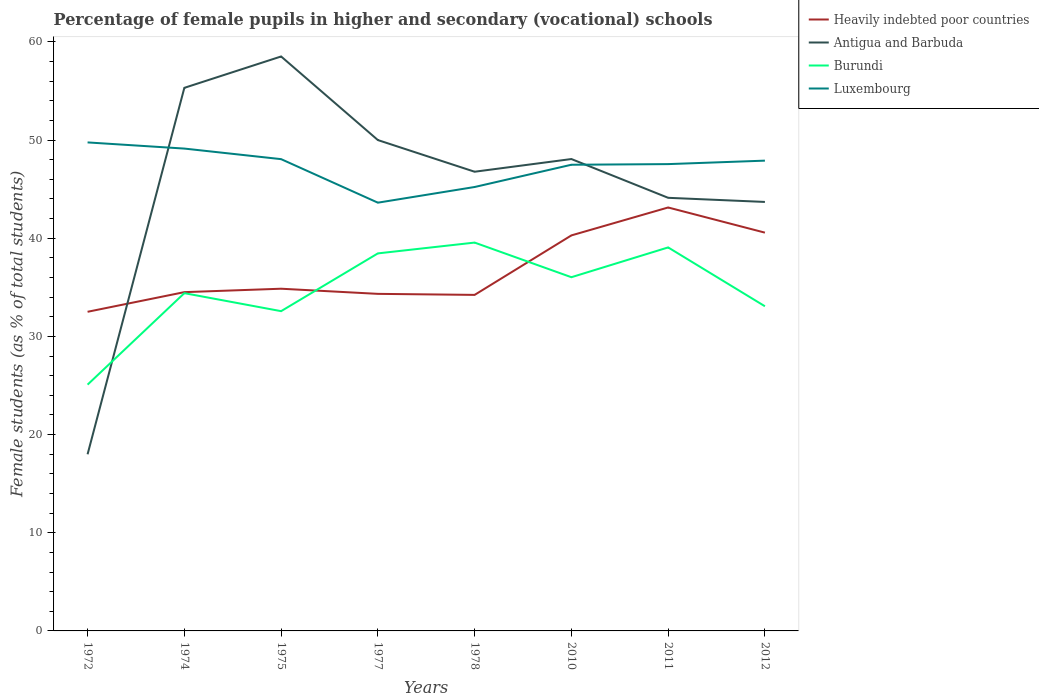How many different coloured lines are there?
Offer a very short reply. 4. Does the line corresponding to Burundi intersect with the line corresponding to Luxembourg?
Provide a succinct answer. No. Across all years, what is the maximum percentage of female pupils in higher and secondary schools in Luxembourg?
Keep it short and to the point. 43.62. In which year was the percentage of female pupils in higher and secondary schools in Burundi maximum?
Your response must be concise. 1972. What is the total percentage of female pupils in higher and secondary schools in Burundi in the graph?
Offer a very short reply. -4.05. What is the difference between the highest and the second highest percentage of female pupils in higher and secondary schools in Luxembourg?
Your answer should be very brief. 6.14. Is the percentage of female pupils in higher and secondary schools in Heavily indebted poor countries strictly greater than the percentage of female pupils in higher and secondary schools in Burundi over the years?
Keep it short and to the point. No. How many lines are there?
Offer a very short reply. 4. How many years are there in the graph?
Keep it short and to the point. 8. Are the values on the major ticks of Y-axis written in scientific E-notation?
Your response must be concise. No. Where does the legend appear in the graph?
Provide a short and direct response. Top right. How many legend labels are there?
Offer a very short reply. 4. What is the title of the graph?
Give a very brief answer. Percentage of female pupils in higher and secondary (vocational) schools. Does "Kosovo" appear as one of the legend labels in the graph?
Give a very brief answer. No. What is the label or title of the X-axis?
Give a very brief answer. Years. What is the label or title of the Y-axis?
Your answer should be very brief. Female students (as % of total students). What is the Female students (as % of total students) of Heavily indebted poor countries in 1972?
Provide a succinct answer. 32.51. What is the Female students (as % of total students) of Antigua and Barbuda in 1972?
Make the answer very short. 17.99. What is the Female students (as % of total students) in Burundi in 1972?
Your answer should be compact. 25.09. What is the Female students (as % of total students) of Luxembourg in 1972?
Offer a very short reply. 49.76. What is the Female students (as % of total students) in Heavily indebted poor countries in 1974?
Make the answer very short. 34.51. What is the Female students (as % of total students) in Antigua and Barbuda in 1974?
Make the answer very short. 55.32. What is the Female students (as % of total students) in Burundi in 1974?
Provide a succinct answer. 34.41. What is the Female students (as % of total students) of Luxembourg in 1974?
Ensure brevity in your answer.  49.13. What is the Female students (as % of total students) of Heavily indebted poor countries in 1975?
Give a very brief answer. 34.86. What is the Female students (as % of total students) of Antigua and Barbuda in 1975?
Give a very brief answer. 58.52. What is the Female students (as % of total students) of Burundi in 1975?
Make the answer very short. 32.57. What is the Female students (as % of total students) in Luxembourg in 1975?
Your answer should be compact. 48.06. What is the Female students (as % of total students) of Heavily indebted poor countries in 1977?
Your response must be concise. 34.33. What is the Female students (as % of total students) of Burundi in 1977?
Offer a very short reply. 38.46. What is the Female students (as % of total students) in Luxembourg in 1977?
Ensure brevity in your answer.  43.62. What is the Female students (as % of total students) of Heavily indebted poor countries in 1978?
Make the answer very short. 34.23. What is the Female students (as % of total students) in Antigua and Barbuda in 1978?
Provide a short and direct response. 46.77. What is the Female students (as % of total students) of Burundi in 1978?
Offer a terse response. 39.56. What is the Female students (as % of total students) in Luxembourg in 1978?
Offer a very short reply. 45.22. What is the Female students (as % of total students) of Heavily indebted poor countries in 2010?
Make the answer very short. 40.29. What is the Female students (as % of total students) in Antigua and Barbuda in 2010?
Offer a terse response. 48.07. What is the Female students (as % of total students) in Burundi in 2010?
Your answer should be compact. 36.03. What is the Female students (as % of total students) in Luxembourg in 2010?
Ensure brevity in your answer.  47.49. What is the Female students (as % of total students) of Heavily indebted poor countries in 2011?
Offer a very short reply. 43.13. What is the Female students (as % of total students) of Antigua and Barbuda in 2011?
Give a very brief answer. 44.12. What is the Female students (as % of total students) in Burundi in 2011?
Provide a short and direct response. 39.06. What is the Female students (as % of total students) of Luxembourg in 2011?
Your answer should be compact. 47.55. What is the Female students (as % of total students) of Heavily indebted poor countries in 2012?
Ensure brevity in your answer.  40.57. What is the Female students (as % of total students) in Antigua and Barbuda in 2012?
Your answer should be compact. 43.7. What is the Female students (as % of total students) in Burundi in 2012?
Make the answer very short. 33.07. What is the Female students (as % of total students) in Luxembourg in 2012?
Give a very brief answer. 47.9. Across all years, what is the maximum Female students (as % of total students) of Heavily indebted poor countries?
Provide a short and direct response. 43.13. Across all years, what is the maximum Female students (as % of total students) of Antigua and Barbuda?
Give a very brief answer. 58.52. Across all years, what is the maximum Female students (as % of total students) of Burundi?
Keep it short and to the point. 39.56. Across all years, what is the maximum Female students (as % of total students) in Luxembourg?
Your answer should be very brief. 49.76. Across all years, what is the minimum Female students (as % of total students) in Heavily indebted poor countries?
Make the answer very short. 32.51. Across all years, what is the minimum Female students (as % of total students) of Antigua and Barbuda?
Offer a very short reply. 17.99. Across all years, what is the minimum Female students (as % of total students) of Burundi?
Offer a very short reply. 25.09. Across all years, what is the minimum Female students (as % of total students) in Luxembourg?
Your response must be concise. 43.62. What is the total Female students (as % of total students) of Heavily indebted poor countries in the graph?
Provide a short and direct response. 294.43. What is the total Female students (as % of total students) of Antigua and Barbuda in the graph?
Give a very brief answer. 364.48. What is the total Female students (as % of total students) of Burundi in the graph?
Give a very brief answer. 278.24. What is the total Female students (as % of total students) of Luxembourg in the graph?
Give a very brief answer. 378.73. What is the difference between the Female students (as % of total students) in Heavily indebted poor countries in 1972 and that in 1974?
Keep it short and to the point. -2. What is the difference between the Female students (as % of total students) in Antigua and Barbuda in 1972 and that in 1974?
Keep it short and to the point. -37.33. What is the difference between the Female students (as % of total students) in Burundi in 1972 and that in 1974?
Offer a very short reply. -9.32. What is the difference between the Female students (as % of total students) in Luxembourg in 1972 and that in 1974?
Provide a succinct answer. 0.63. What is the difference between the Female students (as % of total students) of Heavily indebted poor countries in 1972 and that in 1975?
Provide a succinct answer. -2.35. What is the difference between the Female students (as % of total students) in Antigua and Barbuda in 1972 and that in 1975?
Keep it short and to the point. -40.52. What is the difference between the Female students (as % of total students) of Burundi in 1972 and that in 1975?
Ensure brevity in your answer.  -7.49. What is the difference between the Female students (as % of total students) of Luxembourg in 1972 and that in 1975?
Ensure brevity in your answer.  1.7. What is the difference between the Female students (as % of total students) of Heavily indebted poor countries in 1972 and that in 1977?
Provide a short and direct response. -1.83. What is the difference between the Female students (as % of total students) of Antigua and Barbuda in 1972 and that in 1977?
Provide a succinct answer. -32.01. What is the difference between the Female students (as % of total students) in Burundi in 1972 and that in 1977?
Offer a terse response. -13.37. What is the difference between the Female students (as % of total students) in Luxembourg in 1972 and that in 1977?
Your answer should be compact. 6.14. What is the difference between the Female students (as % of total students) of Heavily indebted poor countries in 1972 and that in 1978?
Your response must be concise. -1.72. What is the difference between the Female students (as % of total students) of Antigua and Barbuda in 1972 and that in 1978?
Provide a succinct answer. -28.78. What is the difference between the Female students (as % of total students) of Burundi in 1972 and that in 1978?
Ensure brevity in your answer.  -14.47. What is the difference between the Female students (as % of total students) of Luxembourg in 1972 and that in 1978?
Offer a very short reply. 4.54. What is the difference between the Female students (as % of total students) in Heavily indebted poor countries in 1972 and that in 2010?
Your answer should be compact. -7.78. What is the difference between the Female students (as % of total students) in Antigua and Barbuda in 1972 and that in 2010?
Keep it short and to the point. -30.08. What is the difference between the Female students (as % of total students) of Burundi in 1972 and that in 2010?
Provide a succinct answer. -10.94. What is the difference between the Female students (as % of total students) in Luxembourg in 1972 and that in 2010?
Your response must be concise. 2.27. What is the difference between the Female students (as % of total students) of Heavily indebted poor countries in 1972 and that in 2011?
Your answer should be compact. -10.62. What is the difference between the Female students (as % of total students) of Antigua and Barbuda in 1972 and that in 2011?
Your answer should be compact. -26.13. What is the difference between the Female students (as % of total students) in Burundi in 1972 and that in 2011?
Your answer should be compact. -13.98. What is the difference between the Female students (as % of total students) of Luxembourg in 1972 and that in 2011?
Give a very brief answer. 2.21. What is the difference between the Female students (as % of total students) in Heavily indebted poor countries in 1972 and that in 2012?
Offer a very short reply. -8.06. What is the difference between the Female students (as % of total students) of Antigua and Barbuda in 1972 and that in 2012?
Provide a succinct answer. -25.71. What is the difference between the Female students (as % of total students) in Burundi in 1972 and that in 2012?
Your response must be concise. -7.98. What is the difference between the Female students (as % of total students) in Luxembourg in 1972 and that in 2012?
Give a very brief answer. 1.86. What is the difference between the Female students (as % of total students) in Heavily indebted poor countries in 1974 and that in 1975?
Keep it short and to the point. -0.35. What is the difference between the Female students (as % of total students) of Antigua and Barbuda in 1974 and that in 1975?
Your answer should be very brief. -3.2. What is the difference between the Female students (as % of total students) of Burundi in 1974 and that in 1975?
Your answer should be compact. 1.83. What is the difference between the Female students (as % of total students) of Luxembourg in 1974 and that in 1975?
Ensure brevity in your answer.  1.08. What is the difference between the Female students (as % of total students) in Heavily indebted poor countries in 1974 and that in 1977?
Provide a short and direct response. 0.18. What is the difference between the Female students (as % of total students) of Antigua and Barbuda in 1974 and that in 1977?
Give a very brief answer. 5.32. What is the difference between the Female students (as % of total students) in Burundi in 1974 and that in 1977?
Your response must be concise. -4.05. What is the difference between the Female students (as % of total students) in Luxembourg in 1974 and that in 1977?
Your answer should be compact. 5.51. What is the difference between the Female students (as % of total students) in Heavily indebted poor countries in 1974 and that in 1978?
Provide a short and direct response. 0.28. What is the difference between the Female students (as % of total students) of Antigua and Barbuda in 1974 and that in 1978?
Your response must be concise. 8.54. What is the difference between the Female students (as % of total students) of Burundi in 1974 and that in 1978?
Make the answer very short. -5.15. What is the difference between the Female students (as % of total students) in Luxembourg in 1974 and that in 1978?
Provide a short and direct response. 3.91. What is the difference between the Female students (as % of total students) in Heavily indebted poor countries in 1974 and that in 2010?
Your answer should be compact. -5.78. What is the difference between the Female students (as % of total students) in Antigua and Barbuda in 1974 and that in 2010?
Offer a very short reply. 7.25. What is the difference between the Female students (as % of total students) in Burundi in 1974 and that in 2010?
Provide a short and direct response. -1.62. What is the difference between the Female students (as % of total students) of Luxembourg in 1974 and that in 2010?
Offer a very short reply. 1.65. What is the difference between the Female students (as % of total students) in Heavily indebted poor countries in 1974 and that in 2011?
Ensure brevity in your answer.  -8.62. What is the difference between the Female students (as % of total students) of Antigua and Barbuda in 1974 and that in 2011?
Your response must be concise. 11.2. What is the difference between the Female students (as % of total students) in Burundi in 1974 and that in 2011?
Give a very brief answer. -4.66. What is the difference between the Female students (as % of total students) in Luxembourg in 1974 and that in 2011?
Your answer should be compact. 1.58. What is the difference between the Female students (as % of total students) of Heavily indebted poor countries in 1974 and that in 2012?
Provide a succinct answer. -6.06. What is the difference between the Female students (as % of total students) in Antigua and Barbuda in 1974 and that in 2012?
Make the answer very short. 11.62. What is the difference between the Female students (as % of total students) of Burundi in 1974 and that in 2012?
Ensure brevity in your answer.  1.33. What is the difference between the Female students (as % of total students) of Luxembourg in 1974 and that in 2012?
Ensure brevity in your answer.  1.23. What is the difference between the Female students (as % of total students) of Heavily indebted poor countries in 1975 and that in 1977?
Make the answer very short. 0.52. What is the difference between the Female students (as % of total students) of Antigua and Barbuda in 1975 and that in 1977?
Offer a very short reply. 8.52. What is the difference between the Female students (as % of total students) of Burundi in 1975 and that in 1977?
Your response must be concise. -5.88. What is the difference between the Female students (as % of total students) in Luxembourg in 1975 and that in 1977?
Offer a terse response. 4.43. What is the difference between the Female students (as % of total students) of Heavily indebted poor countries in 1975 and that in 1978?
Your answer should be very brief. 0.63. What is the difference between the Female students (as % of total students) of Antigua and Barbuda in 1975 and that in 1978?
Offer a terse response. 11.74. What is the difference between the Female students (as % of total students) of Burundi in 1975 and that in 1978?
Keep it short and to the point. -6.98. What is the difference between the Female students (as % of total students) in Luxembourg in 1975 and that in 1978?
Offer a very short reply. 2.84. What is the difference between the Female students (as % of total students) of Heavily indebted poor countries in 1975 and that in 2010?
Provide a short and direct response. -5.43. What is the difference between the Female students (as % of total students) in Antigua and Barbuda in 1975 and that in 2010?
Provide a succinct answer. 10.45. What is the difference between the Female students (as % of total students) of Burundi in 1975 and that in 2010?
Offer a very short reply. -3.46. What is the difference between the Female students (as % of total students) of Luxembourg in 1975 and that in 2010?
Your answer should be compact. 0.57. What is the difference between the Female students (as % of total students) of Heavily indebted poor countries in 1975 and that in 2011?
Keep it short and to the point. -8.27. What is the difference between the Female students (as % of total students) of Antigua and Barbuda in 1975 and that in 2011?
Give a very brief answer. 14.4. What is the difference between the Female students (as % of total students) of Burundi in 1975 and that in 2011?
Your response must be concise. -6.49. What is the difference between the Female students (as % of total students) in Luxembourg in 1975 and that in 2011?
Keep it short and to the point. 0.51. What is the difference between the Female students (as % of total students) of Heavily indebted poor countries in 1975 and that in 2012?
Offer a terse response. -5.71. What is the difference between the Female students (as % of total students) of Antigua and Barbuda in 1975 and that in 2012?
Make the answer very short. 14.82. What is the difference between the Female students (as % of total students) in Burundi in 1975 and that in 2012?
Ensure brevity in your answer.  -0.5. What is the difference between the Female students (as % of total students) in Luxembourg in 1975 and that in 2012?
Give a very brief answer. 0.15. What is the difference between the Female students (as % of total students) in Heavily indebted poor countries in 1977 and that in 1978?
Your response must be concise. 0.1. What is the difference between the Female students (as % of total students) in Antigua and Barbuda in 1977 and that in 1978?
Provide a short and direct response. 3.23. What is the difference between the Female students (as % of total students) of Burundi in 1977 and that in 1978?
Provide a short and direct response. -1.1. What is the difference between the Female students (as % of total students) of Luxembourg in 1977 and that in 1978?
Ensure brevity in your answer.  -1.6. What is the difference between the Female students (as % of total students) in Heavily indebted poor countries in 1977 and that in 2010?
Ensure brevity in your answer.  -5.96. What is the difference between the Female students (as % of total students) of Antigua and Barbuda in 1977 and that in 2010?
Offer a very short reply. 1.93. What is the difference between the Female students (as % of total students) in Burundi in 1977 and that in 2010?
Make the answer very short. 2.43. What is the difference between the Female students (as % of total students) in Luxembourg in 1977 and that in 2010?
Give a very brief answer. -3.86. What is the difference between the Female students (as % of total students) in Heavily indebted poor countries in 1977 and that in 2011?
Ensure brevity in your answer.  -8.8. What is the difference between the Female students (as % of total students) of Antigua and Barbuda in 1977 and that in 2011?
Your answer should be compact. 5.88. What is the difference between the Female students (as % of total students) in Burundi in 1977 and that in 2011?
Offer a very short reply. -0.61. What is the difference between the Female students (as % of total students) of Luxembourg in 1977 and that in 2011?
Offer a terse response. -3.93. What is the difference between the Female students (as % of total students) of Heavily indebted poor countries in 1977 and that in 2012?
Keep it short and to the point. -6.24. What is the difference between the Female students (as % of total students) of Antigua and Barbuda in 1977 and that in 2012?
Provide a succinct answer. 6.3. What is the difference between the Female students (as % of total students) in Burundi in 1977 and that in 2012?
Give a very brief answer. 5.39. What is the difference between the Female students (as % of total students) in Luxembourg in 1977 and that in 2012?
Keep it short and to the point. -4.28. What is the difference between the Female students (as % of total students) of Heavily indebted poor countries in 1978 and that in 2010?
Provide a short and direct response. -6.06. What is the difference between the Female students (as % of total students) of Antigua and Barbuda in 1978 and that in 2010?
Offer a terse response. -1.29. What is the difference between the Female students (as % of total students) of Burundi in 1978 and that in 2010?
Offer a very short reply. 3.53. What is the difference between the Female students (as % of total students) in Luxembourg in 1978 and that in 2010?
Provide a short and direct response. -2.27. What is the difference between the Female students (as % of total students) in Heavily indebted poor countries in 1978 and that in 2011?
Keep it short and to the point. -8.9. What is the difference between the Female students (as % of total students) of Antigua and Barbuda in 1978 and that in 2011?
Provide a succinct answer. 2.66. What is the difference between the Female students (as % of total students) of Burundi in 1978 and that in 2011?
Provide a succinct answer. 0.49. What is the difference between the Female students (as % of total students) of Luxembourg in 1978 and that in 2011?
Provide a short and direct response. -2.33. What is the difference between the Female students (as % of total students) in Heavily indebted poor countries in 1978 and that in 2012?
Keep it short and to the point. -6.34. What is the difference between the Female students (as % of total students) in Antigua and Barbuda in 1978 and that in 2012?
Provide a succinct answer. 3.08. What is the difference between the Female students (as % of total students) of Burundi in 1978 and that in 2012?
Provide a succinct answer. 6.49. What is the difference between the Female students (as % of total students) in Luxembourg in 1978 and that in 2012?
Offer a very short reply. -2.69. What is the difference between the Female students (as % of total students) in Heavily indebted poor countries in 2010 and that in 2011?
Keep it short and to the point. -2.84. What is the difference between the Female students (as % of total students) of Antigua and Barbuda in 2010 and that in 2011?
Offer a terse response. 3.95. What is the difference between the Female students (as % of total students) in Burundi in 2010 and that in 2011?
Offer a terse response. -3.04. What is the difference between the Female students (as % of total students) of Luxembourg in 2010 and that in 2011?
Make the answer very short. -0.06. What is the difference between the Female students (as % of total students) in Heavily indebted poor countries in 2010 and that in 2012?
Make the answer very short. -0.28. What is the difference between the Female students (as % of total students) in Antigua and Barbuda in 2010 and that in 2012?
Ensure brevity in your answer.  4.37. What is the difference between the Female students (as % of total students) in Burundi in 2010 and that in 2012?
Offer a very short reply. 2.96. What is the difference between the Female students (as % of total students) in Luxembourg in 2010 and that in 2012?
Give a very brief answer. -0.42. What is the difference between the Female students (as % of total students) of Heavily indebted poor countries in 2011 and that in 2012?
Offer a terse response. 2.56. What is the difference between the Female students (as % of total students) of Antigua and Barbuda in 2011 and that in 2012?
Your answer should be compact. 0.42. What is the difference between the Female students (as % of total students) of Burundi in 2011 and that in 2012?
Make the answer very short. 5.99. What is the difference between the Female students (as % of total students) of Luxembourg in 2011 and that in 2012?
Your answer should be compact. -0.35. What is the difference between the Female students (as % of total students) in Heavily indebted poor countries in 1972 and the Female students (as % of total students) in Antigua and Barbuda in 1974?
Provide a short and direct response. -22.81. What is the difference between the Female students (as % of total students) of Heavily indebted poor countries in 1972 and the Female students (as % of total students) of Burundi in 1974?
Provide a short and direct response. -1.9. What is the difference between the Female students (as % of total students) of Heavily indebted poor countries in 1972 and the Female students (as % of total students) of Luxembourg in 1974?
Give a very brief answer. -16.63. What is the difference between the Female students (as % of total students) in Antigua and Barbuda in 1972 and the Female students (as % of total students) in Burundi in 1974?
Provide a short and direct response. -16.41. What is the difference between the Female students (as % of total students) in Antigua and Barbuda in 1972 and the Female students (as % of total students) in Luxembourg in 1974?
Give a very brief answer. -31.14. What is the difference between the Female students (as % of total students) of Burundi in 1972 and the Female students (as % of total students) of Luxembourg in 1974?
Keep it short and to the point. -24.05. What is the difference between the Female students (as % of total students) in Heavily indebted poor countries in 1972 and the Female students (as % of total students) in Antigua and Barbuda in 1975?
Provide a succinct answer. -26.01. What is the difference between the Female students (as % of total students) of Heavily indebted poor countries in 1972 and the Female students (as % of total students) of Burundi in 1975?
Make the answer very short. -0.07. What is the difference between the Female students (as % of total students) of Heavily indebted poor countries in 1972 and the Female students (as % of total students) of Luxembourg in 1975?
Provide a succinct answer. -15.55. What is the difference between the Female students (as % of total students) in Antigua and Barbuda in 1972 and the Female students (as % of total students) in Burundi in 1975?
Offer a very short reply. -14.58. What is the difference between the Female students (as % of total students) of Antigua and Barbuda in 1972 and the Female students (as % of total students) of Luxembourg in 1975?
Keep it short and to the point. -30.07. What is the difference between the Female students (as % of total students) in Burundi in 1972 and the Female students (as % of total students) in Luxembourg in 1975?
Make the answer very short. -22.97. What is the difference between the Female students (as % of total students) in Heavily indebted poor countries in 1972 and the Female students (as % of total students) in Antigua and Barbuda in 1977?
Keep it short and to the point. -17.49. What is the difference between the Female students (as % of total students) of Heavily indebted poor countries in 1972 and the Female students (as % of total students) of Burundi in 1977?
Give a very brief answer. -5.95. What is the difference between the Female students (as % of total students) of Heavily indebted poor countries in 1972 and the Female students (as % of total students) of Luxembourg in 1977?
Make the answer very short. -11.12. What is the difference between the Female students (as % of total students) of Antigua and Barbuda in 1972 and the Female students (as % of total students) of Burundi in 1977?
Provide a succinct answer. -20.46. What is the difference between the Female students (as % of total students) in Antigua and Barbuda in 1972 and the Female students (as % of total students) in Luxembourg in 1977?
Offer a very short reply. -25.63. What is the difference between the Female students (as % of total students) in Burundi in 1972 and the Female students (as % of total students) in Luxembourg in 1977?
Your answer should be compact. -18.54. What is the difference between the Female students (as % of total students) of Heavily indebted poor countries in 1972 and the Female students (as % of total students) of Antigua and Barbuda in 1978?
Your answer should be compact. -14.27. What is the difference between the Female students (as % of total students) of Heavily indebted poor countries in 1972 and the Female students (as % of total students) of Burundi in 1978?
Offer a terse response. -7.05. What is the difference between the Female students (as % of total students) in Heavily indebted poor countries in 1972 and the Female students (as % of total students) in Luxembourg in 1978?
Your response must be concise. -12.71. What is the difference between the Female students (as % of total students) of Antigua and Barbuda in 1972 and the Female students (as % of total students) of Burundi in 1978?
Offer a very short reply. -21.57. What is the difference between the Female students (as % of total students) in Antigua and Barbuda in 1972 and the Female students (as % of total students) in Luxembourg in 1978?
Your answer should be compact. -27.23. What is the difference between the Female students (as % of total students) of Burundi in 1972 and the Female students (as % of total students) of Luxembourg in 1978?
Your response must be concise. -20.13. What is the difference between the Female students (as % of total students) of Heavily indebted poor countries in 1972 and the Female students (as % of total students) of Antigua and Barbuda in 2010?
Give a very brief answer. -15.56. What is the difference between the Female students (as % of total students) of Heavily indebted poor countries in 1972 and the Female students (as % of total students) of Burundi in 2010?
Offer a terse response. -3.52. What is the difference between the Female students (as % of total students) in Heavily indebted poor countries in 1972 and the Female students (as % of total students) in Luxembourg in 2010?
Offer a terse response. -14.98. What is the difference between the Female students (as % of total students) in Antigua and Barbuda in 1972 and the Female students (as % of total students) in Burundi in 2010?
Your answer should be compact. -18.04. What is the difference between the Female students (as % of total students) in Antigua and Barbuda in 1972 and the Female students (as % of total students) in Luxembourg in 2010?
Your answer should be very brief. -29.49. What is the difference between the Female students (as % of total students) in Burundi in 1972 and the Female students (as % of total students) in Luxembourg in 2010?
Provide a short and direct response. -22.4. What is the difference between the Female students (as % of total students) in Heavily indebted poor countries in 1972 and the Female students (as % of total students) in Antigua and Barbuda in 2011?
Make the answer very short. -11.61. What is the difference between the Female students (as % of total students) of Heavily indebted poor countries in 1972 and the Female students (as % of total students) of Burundi in 2011?
Offer a very short reply. -6.56. What is the difference between the Female students (as % of total students) of Heavily indebted poor countries in 1972 and the Female students (as % of total students) of Luxembourg in 2011?
Your response must be concise. -15.04. What is the difference between the Female students (as % of total students) in Antigua and Barbuda in 1972 and the Female students (as % of total students) in Burundi in 2011?
Your response must be concise. -21.07. What is the difference between the Female students (as % of total students) in Antigua and Barbuda in 1972 and the Female students (as % of total students) in Luxembourg in 2011?
Give a very brief answer. -29.56. What is the difference between the Female students (as % of total students) of Burundi in 1972 and the Female students (as % of total students) of Luxembourg in 2011?
Provide a short and direct response. -22.46. What is the difference between the Female students (as % of total students) in Heavily indebted poor countries in 1972 and the Female students (as % of total students) in Antigua and Barbuda in 2012?
Ensure brevity in your answer.  -11.19. What is the difference between the Female students (as % of total students) in Heavily indebted poor countries in 1972 and the Female students (as % of total students) in Burundi in 2012?
Ensure brevity in your answer.  -0.56. What is the difference between the Female students (as % of total students) in Heavily indebted poor countries in 1972 and the Female students (as % of total students) in Luxembourg in 2012?
Provide a succinct answer. -15.4. What is the difference between the Female students (as % of total students) in Antigua and Barbuda in 1972 and the Female students (as % of total students) in Burundi in 2012?
Offer a very short reply. -15.08. What is the difference between the Female students (as % of total students) in Antigua and Barbuda in 1972 and the Female students (as % of total students) in Luxembourg in 2012?
Offer a terse response. -29.91. What is the difference between the Female students (as % of total students) in Burundi in 1972 and the Female students (as % of total students) in Luxembourg in 2012?
Make the answer very short. -22.82. What is the difference between the Female students (as % of total students) in Heavily indebted poor countries in 1974 and the Female students (as % of total students) in Antigua and Barbuda in 1975?
Offer a terse response. -24.01. What is the difference between the Female students (as % of total students) of Heavily indebted poor countries in 1974 and the Female students (as % of total students) of Burundi in 1975?
Provide a succinct answer. 1.94. What is the difference between the Female students (as % of total students) in Heavily indebted poor countries in 1974 and the Female students (as % of total students) in Luxembourg in 1975?
Your answer should be very brief. -13.55. What is the difference between the Female students (as % of total students) of Antigua and Barbuda in 1974 and the Female students (as % of total students) of Burundi in 1975?
Your answer should be very brief. 22.75. What is the difference between the Female students (as % of total students) in Antigua and Barbuda in 1974 and the Female students (as % of total students) in Luxembourg in 1975?
Keep it short and to the point. 7.26. What is the difference between the Female students (as % of total students) of Burundi in 1974 and the Female students (as % of total students) of Luxembourg in 1975?
Provide a succinct answer. -13.65. What is the difference between the Female students (as % of total students) in Heavily indebted poor countries in 1974 and the Female students (as % of total students) in Antigua and Barbuda in 1977?
Make the answer very short. -15.49. What is the difference between the Female students (as % of total students) of Heavily indebted poor countries in 1974 and the Female students (as % of total students) of Burundi in 1977?
Ensure brevity in your answer.  -3.95. What is the difference between the Female students (as % of total students) in Heavily indebted poor countries in 1974 and the Female students (as % of total students) in Luxembourg in 1977?
Give a very brief answer. -9.11. What is the difference between the Female students (as % of total students) of Antigua and Barbuda in 1974 and the Female students (as % of total students) of Burundi in 1977?
Ensure brevity in your answer.  16.86. What is the difference between the Female students (as % of total students) of Antigua and Barbuda in 1974 and the Female students (as % of total students) of Luxembourg in 1977?
Ensure brevity in your answer.  11.7. What is the difference between the Female students (as % of total students) of Burundi in 1974 and the Female students (as % of total students) of Luxembourg in 1977?
Your answer should be compact. -9.22. What is the difference between the Female students (as % of total students) of Heavily indebted poor countries in 1974 and the Female students (as % of total students) of Antigua and Barbuda in 1978?
Your answer should be compact. -12.27. What is the difference between the Female students (as % of total students) in Heavily indebted poor countries in 1974 and the Female students (as % of total students) in Burundi in 1978?
Your answer should be compact. -5.05. What is the difference between the Female students (as % of total students) of Heavily indebted poor countries in 1974 and the Female students (as % of total students) of Luxembourg in 1978?
Give a very brief answer. -10.71. What is the difference between the Female students (as % of total students) in Antigua and Barbuda in 1974 and the Female students (as % of total students) in Burundi in 1978?
Make the answer very short. 15.76. What is the difference between the Female students (as % of total students) in Antigua and Barbuda in 1974 and the Female students (as % of total students) in Luxembourg in 1978?
Your answer should be very brief. 10.1. What is the difference between the Female students (as % of total students) in Burundi in 1974 and the Female students (as % of total students) in Luxembourg in 1978?
Keep it short and to the point. -10.81. What is the difference between the Female students (as % of total students) in Heavily indebted poor countries in 1974 and the Female students (as % of total students) in Antigua and Barbuda in 2010?
Provide a short and direct response. -13.56. What is the difference between the Female students (as % of total students) of Heavily indebted poor countries in 1974 and the Female students (as % of total students) of Burundi in 2010?
Keep it short and to the point. -1.52. What is the difference between the Female students (as % of total students) in Heavily indebted poor countries in 1974 and the Female students (as % of total students) in Luxembourg in 2010?
Your response must be concise. -12.98. What is the difference between the Female students (as % of total students) in Antigua and Barbuda in 1974 and the Female students (as % of total students) in Burundi in 2010?
Make the answer very short. 19.29. What is the difference between the Female students (as % of total students) in Antigua and Barbuda in 1974 and the Female students (as % of total students) in Luxembourg in 2010?
Your response must be concise. 7.83. What is the difference between the Female students (as % of total students) in Burundi in 1974 and the Female students (as % of total students) in Luxembourg in 2010?
Make the answer very short. -13.08. What is the difference between the Female students (as % of total students) of Heavily indebted poor countries in 1974 and the Female students (as % of total students) of Antigua and Barbuda in 2011?
Your answer should be compact. -9.61. What is the difference between the Female students (as % of total students) of Heavily indebted poor countries in 1974 and the Female students (as % of total students) of Burundi in 2011?
Your answer should be very brief. -4.56. What is the difference between the Female students (as % of total students) in Heavily indebted poor countries in 1974 and the Female students (as % of total students) in Luxembourg in 2011?
Provide a short and direct response. -13.04. What is the difference between the Female students (as % of total students) of Antigua and Barbuda in 1974 and the Female students (as % of total students) of Burundi in 2011?
Keep it short and to the point. 16.25. What is the difference between the Female students (as % of total students) of Antigua and Barbuda in 1974 and the Female students (as % of total students) of Luxembourg in 2011?
Your response must be concise. 7.77. What is the difference between the Female students (as % of total students) in Burundi in 1974 and the Female students (as % of total students) in Luxembourg in 2011?
Keep it short and to the point. -13.14. What is the difference between the Female students (as % of total students) in Heavily indebted poor countries in 1974 and the Female students (as % of total students) in Antigua and Barbuda in 2012?
Offer a terse response. -9.19. What is the difference between the Female students (as % of total students) of Heavily indebted poor countries in 1974 and the Female students (as % of total students) of Burundi in 2012?
Keep it short and to the point. 1.44. What is the difference between the Female students (as % of total students) in Heavily indebted poor countries in 1974 and the Female students (as % of total students) in Luxembourg in 2012?
Give a very brief answer. -13.4. What is the difference between the Female students (as % of total students) in Antigua and Barbuda in 1974 and the Female students (as % of total students) in Burundi in 2012?
Offer a very short reply. 22.25. What is the difference between the Female students (as % of total students) of Antigua and Barbuda in 1974 and the Female students (as % of total students) of Luxembourg in 2012?
Offer a terse response. 7.42. What is the difference between the Female students (as % of total students) of Burundi in 1974 and the Female students (as % of total students) of Luxembourg in 2012?
Offer a terse response. -13.5. What is the difference between the Female students (as % of total students) of Heavily indebted poor countries in 1975 and the Female students (as % of total students) of Antigua and Barbuda in 1977?
Provide a short and direct response. -15.14. What is the difference between the Female students (as % of total students) of Heavily indebted poor countries in 1975 and the Female students (as % of total students) of Burundi in 1977?
Keep it short and to the point. -3.6. What is the difference between the Female students (as % of total students) in Heavily indebted poor countries in 1975 and the Female students (as % of total students) in Luxembourg in 1977?
Offer a very short reply. -8.76. What is the difference between the Female students (as % of total students) of Antigua and Barbuda in 1975 and the Female students (as % of total students) of Burundi in 1977?
Provide a short and direct response. 20.06. What is the difference between the Female students (as % of total students) of Antigua and Barbuda in 1975 and the Female students (as % of total students) of Luxembourg in 1977?
Offer a very short reply. 14.89. What is the difference between the Female students (as % of total students) in Burundi in 1975 and the Female students (as % of total students) in Luxembourg in 1977?
Offer a very short reply. -11.05. What is the difference between the Female students (as % of total students) of Heavily indebted poor countries in 1975 and the Female students (as % of total students) of Antigua and Barbuda in 1978?
Your response must be concise. -11.92. What is the difference between the Female students (as % of total students) of Heavily indebted poor countries in 1975 and the Female students (as % of total students) of Burundi in 1978?
Offer a very short reply. -4.7. What is the difference between the Female students (as % of total students) of Heavily indebted poor countries in 1975 and the Female students (as % of total students) of Luxembourg in 1978?
Provide a succinct answer. -10.36. What is the difference between the Female students (as % of total students) of Antigua and Barbuda in 1975 and the Female students (as % of total students) of Burundi in 1978?
Your answer should be very brief. 18.96. What is the difference between the Female students (as % of total students) in Antigua and Barbuda in 1975 and the Female students (as % of total students) in Luxembourg in 1978?
Offer a very short reply. 13.3. What is the difference between the Female students (as % of total students) of Burundi in 1975 and the Female students (as % of total students) of Luxembourg in 1978?
Offer a terse response. -12.65. What is the difference between the Female students (as % of total students) of Heavily indebted poor countries in 1975 and the Female students (as % of total students) of Antigua and Barbuda in 2010?
Give a very brief answer. -13.21. What is the difference between the Female students (as % of total students) in Heavily indebted poor countries in 1975 and the Female students (as % of total students) in Burundi in 2010?
Give a very brief answer. -1.17. What is the difference between the Female students (as % of total students) of Heavily indebted poor countries in 1975 and the Female students (as % of total students) of Luxembourg in 2010?
Provide a succinct answer. -12.63. What is the difference between the Female students (as % of total students) of Antigua and Barbuda in 1975 and the Female students (as % of total students) of Burundi in 2010?
Give a very brief answer. 22.49. What is the difference between the Female students (as % of total students) in Antigua and Barbuda in 1975 and the Female students (as % of total students) in Luxembourg in 2010?
Your answer should be very brief. 11.03. What is the difference between the Female students (as % of total students) in Burundi in 1975 and the Female students (as % of total students) in Luxembourg in 2010?
Offer a terse response. -14.91. What is the difference between the Female students (as % of total students) in Heavily indebted poor countries in 1975 and the Female students (as % of total students) in Antigua and Barbuda in 2011?
Offer a terse response. -9.26. What is the difference between the Female students (as % of total students) in Heavily indebted poor countries in 1975 and the Female students (as % of total students) in Burundi in 2011?
Offer a very short reply. -4.21. What is the difference between the Female students (as % of total students) of Heavily indebted poor countries in 1975 and the Female students (as % of total students) of Luxembourg in 2011?
Keep it short and to the point. -12.69. What is the difference between the Female students (as % of total students) of Antigua and Barbuda in 1975 and the Female students (as % of total students) of Burundi in 2011?
Make the answer very short. 19.45. What is the difference between the Female students (as % of total students) of Antigua and Barbuda in 1975 and the Female students (as % of total students) of Luxembourg in 2011?
Provide a succinct answer. 10.97. What is the difference between the Female students (as % of total students) in Burundi in 1975 and the Female students (as % of total students) in Luxembourg in 2011?
Your answer should be compact. -14.98. What is the difference between the Female students (as % of total students) of Heavily indebted poor countries in 1975 and the Female students (as % of total students) of Antigua and Barbuda in 2012?
Make the answer very short. -8.84. What is the difference between the Female students (as % of total students) in Heavily indebted poor countries in 1975 and the Female students (as % of total students) in Burundi in 2012?
Offer a terse response. 1.79. What is the difference between the Female students (as % of total students) in Heavily indebted poor countries in 1975 and the Female students (as % of total students) in Luxembourg in 2012?
Make the answer very short. -13.05. What is the difference between the Female students (as % of total students) of Antigua and Barbuda in 1975 and the Female students (as % of total students) of Burundi in 2012?
Your answer should be very brief. 25.44. What is the difference between the Female students (as % of total students) of Antigua and Barbuda in 1975 and the Female students (as % of total students) of Luxembourg in 2012?
Your response must be concise. 10.61. What is the difference between the Female students (as % of total students) of Burundi in 1975 and the Female students (as % of total students) of Luxembourg in 2012?
Offer a very short reply. -15.33. What is the difference between the Female students (as % of total students) in Heavily indebted poor countries in 1977 and the Female students (as % of total students) in Antigua and Barbuda in 1978?
Offer a terse response. -12.44. What is the difference between the Female students (as % of total students) of Heavily indebted poor countries in 1977 and the Female students (as % of total students) of Burundi in 1978?
Give a very brief answer. -5.22. What is the difference between the Female students (as % of total students) in Heavily indebted poor countries in 1977 and the Female students (as % of total students) in Luxembourg in 1978?
Offer a very short reply. -10.89. What is the difference between the Female students (as % of total students) in Antigua and Barbuda in 1977 and the Female students (as % of total students) in Burundi in 1978?
Provide a short and direct response. 10.44. What is the difference between the Female students (as % of total students) of Antigua and Barbuda in 1977 and the Female students (as % of total students) of Luxembourg in 1978?
Offer a very short reply. 4.78. What is the difference between the Female students (as % of total students) of Burundi in 1977 and the Female students (as % of total students) of Luxembourg in 1978?
Provide a short and direct response. -6.76. What is the difference between the Female students (as % of total students) in Heavily indebted poor countries in 1977 and the Female students (as % of total students) in Antigua and Barbuda in 2010?
Your answer should be compact. -13.73. What is the difference between the Female students (as % of total students) of Heavily indebted poor countries in 1977 and the Female students (as % of total students) of Burundi in 2010?
Make the answer very short. -1.7. What is the difference between the Female students (as % of total students) of Heavily indebted poor countries in 1977 and the Female students (as % of total students) of Luxembourg in 2010?
Your answer should be compact. -13.15. What is the difference between the Female students (as % of total students) of Antigua and Barbuda in 1977 and the Female students (as % of total students) of Burundi in 2010?
Offer a terse response. 13.97. What is the difference between the Female students (as % of total students) of Antigua and Barbuda in 1977 and the Female students (as % of total students) of Luxembourg in 2010?
Your response must be concise. 2.51. What is the difference between the Female students (as % of total students) of Burundi in 1977 and the Female students (as % of total students) of Luxembourg in 2010?
Your answer should be very brief. -9.03. What is the difference between the Female students (as % of total students) in Heavily indebted poor countries in 1977 and the Female students (as % of total students) in Antigua and Barbuda in 2011?
Provide a succinct answer. -9.78. What is the difference between the Female students (as % of total students) in Heavily indebted poor countries in 1977 and the Female students (as % of total students) in Burundi in 2011?
Ensure brevity in your answer.  -4.73. What is the difference between the Female students (as % of total students) in Heavily indebted poor countries in 1977 and the Female students (as % of total students) in Luxembourg in 2011?
Make the answer very short. -13.22. What is the difference between the Female students (as % of total students) in Antigua and Barbuda in 1977 and the Female students (as % of total students) in Burundi in 2011?
Offer a terse response. 10.94. What is the difference between the Female students (as % of total students) of Antigua and Barbuda in 1977 and the Female students (as % of total students) of Luxembourg in 2011?
Provide a short and direct response. 2.45. What is the difference between the Female students (as % of total students) in Burundi in 1977 and the Female students (as % of total students) in Luxembourg in 2011?
Offer a terse response. -9.09. What is the difference between the Female students (as % of total students) in Heavily indebted poor countries in 1977 and the Female students (as % of total students) in Antigua and Barbuda in 2012?
Provide a succinct answer. -9.36. What is the difference between the Female students (as % of total students) of Heavily indebted poor countries in 1977 and the Female students (as % of total students) of Burundi in 2012?
Offer a very short reply. 1.26. What is the difference between the Female students (as % of total students) of Heavily indebted poor countries in 1977 and the Female students (as % of total students) of Luxembourg in 2012?
Make the answer very short. -13.57. What is the difference between the Female students (as % of total students) in Antigua and Barbuda in 1977 and the Female students (as % of total students) in Burundi in 2012?
Offer a very short reply. 16.93. What is the difference between the Female students (as % of total students) of Antigua and Barbuda in 1977 and the Female students (as % of total students) of Luxembourg in 2012?
Your response must be concise. 2.1. What is the difference between the Female students (as % of total students) of Burundi in 1977 and the Female students (as % of total students) of Luxembourg in 2012?
Offer a terse response. -9.45. What is the difference between the Female students (as % of total students) in Heavily indebted poor countries in 1978 and the Female students (as % of total students) in Antigua and Barbuda in 2010?
Give a very brief answer. -13.84. What is the difference between the Female students (as % of total students) in Heavily indebted poor countries in 1978 and the Female students (as % of total students) in Burundi in 2010?
Your answer should be compact. -1.8. What is the difference between the Female students (as % of total students) in Heavily indebted poor countries in 1978 and the Female students (as % of total students) in Luxembourg in 2010?
Your answer should be compact. -13.26. What is the difference between the Female students (as % of total students) of Antigua and Barbuda in 1978 and the Female students (as % of total students) of Burundi in 2010?
Keep it short and to the point. 10.74. What is the difference between the Female students (as % of total students) in Antigua and Barbuda in 1978 and the Female students (as % of total students) in Luxembourg in 2010?
Ensure brevity in your answer.  -0.71. What is the difference between the Female students (as % of total students) of Burundi in 1978 and the Female students (as % of total students) of Luxembourg in 2010?
Provide a short and direct response. -7.93. What is the difference between the Female students (as % of total students) of Heavily indebted poor countries in 1978 and the Female students (as % of total students) of Antigua and Barbuda in 2011?
Provide a short and direct response. -9.89. What is the difference between the Female students (as % of total students) in Heavily indebted poor countries in 1978 and the Female students (as % of total students) in Burundi in 2011?
Your response must be concise. -4.84. What is the difference between the Female students (as % of total students) of Heavily indebted poor countries in 1978 and the Female students (as % of total students) of Luxembourg in 2011?
Offer a very short reply. -13.32. What is the difference between the Female students (as % of total students) of Antigua and Barbuda in 1978 and the Female students (as % of total students) of Burundi in 2011?
Ensure brevity in your answer.  7.71. What is the difference between the Female students (as % of total students) of Antigua and Barbuda in 1978 and the Female students (as % of total students) of Luxembourg in 2011?
Ensure brevity in your answer.  -0.78. What is the difference between the Female students (as % of total students) of Burundi in 1978 and the Female students (as % of total students) of Luxembourg in 2011?
Offer a terse response. -7.99. What is the difference between the Female students (as % of total students) in Heavily indebted poor countries in 1978 and the Female students (as % of total students) in Antigua and Barbuda in 2012?
Offer a terse response. -9.47. What is the difference between the Female students (as % of total students) of Heavily indebted poor countries in 1978 and the Female students (as % of total students) of Burundi in 2012?
Provide a succinct answer. 1.16. What is the difference between the Female students (as % of total students) in Heavily indebted poor countries in 1978 and the Female students (as % of total students) in Luxembourg in 2012?
Provide a succinct answer. -13.67. What is the difference between the Female students (as % of total students) in Antigua and Barbuda in 1978 and the Female students (as % of total students) in Burundi in 2012?
Offer a terse response. 13.7. What is the difference between the Female students (as % of total students) in Antigua and Barbuda in 1978 and the Female students (as % of total students) in Luxembourg in 2012?
Your answer should be compact. -1.13. What is the difference between the Female students (as % of total students) of Burundi in 1978 and the Female students (as % of total students) of Luxembourg in 2012?
Your answer should be compact. -8.35. What is the difference between the Female students (as % of total students) in Heavily indebted poor countries in 2010 and the Female students (as % of total students) in Antigua and Barbuda in 2011?
Your answer should be compact. -3.83. What is the difference between the Female students (as % of total students) of Heavily indebted poor countries in 2010 and the Female students (as % of total students) of Burundi in 2011?
Give a very brief answer. 1.22. What is the difference between the Female students (as % of total students) of Heavily indebted poor countries in 2010 and the Female students (as % of total students) of Luxembourg in 2011?
Your answer should be compact. -7.26. What is the difference between the Female students (as % of total students) in Antigua and Barbuda in 2010 and the Female students (as % of total students) in Burundi in 2011?
Offer a very short reply. 9. What is the difference between the Female students (as % of total students) of Antigua and Barbuda in 2010 and the Female students (as % of total students) of Luxembourg in 2011?
Ensure brevity in your answer.  0.52. What is the difference between the Female students (as % of total students) of Burundi in 2010 and the Female students (as % of total students) of Luxembourg in 2011?
Make the answer very short. -11.52. What is the difference between the Female students (as % of total students) in Heavily indebted poor countries in 2010 and the Female students (as % of total students) in Antigua and Barbuda in 2012?
Ensure brevity in your answer.  -3.41. What is the difference between the Female students (as % of total students) of Heavily indebted poor countries in 2010 and the Female students (as % of total students) of Burundi in 2012?
Provide a short and direct response. 7.22. What is the difference between the Female students (as % of total students) of Heavily indebted poor countries in 2010 and the Female students (as % of total students) of Luxembourg in 2012?
Your answer should be very brief. -7.62. What is the difference between the Female students (as % of total students) of Antigua and Barbuda in 2010 and the Female students (as % of total students) of Burundi in 2012?
Ensure brevity in your answer.  15. What is the difference between the Female students (as % of total students) of Antigua and Barbuda in 2010 and the Female students (as % of total students) of Luxembourg in 2012?
Provide a short and direct response. 0.16. What is the difference between the Female students (as % of total students) in Burundi in 2010 and the Female students (as % of total students) in Luxembourg in 2012?
Ensure brevity in your answer.  -11.87. What is the difference between the Female students (as % of total students) of Heavily indebted poor countries in 2011 and the Female students (as % of total students) of Antigua and Barbuda in 2012?
Provide a short and direct response. -0.57. What is the difference between the Female students (as % of total students) in Heavily indebted poor countries in 2011 and the Female students (as % of total students) in Burundi in 2012?
Ensure brevity in your answer.  10.06. What is the difference between the Female students (as % of total students) of Heavily indebted poor countries in 2011 and the Female students (as % of total students) of Luxembourg in 2012?
Keep it short and to the point. -4.77. What is the difference between the Female students (as % of total students) of Antigua and Barbuda in 2011 and the Female students (as % of total students) of Burundi in 2012?
Your answer should be very brief. 11.05. What is the difference between the Female students (as % of total students) of Antigua and Barbuda in 2011 and the Female students (as % of total students) of Luxembourg in 2012?
Provide a succinct answer. -3.79. What is the difference between the Female students (as % of total students) of Burundi in 2011 and the Female students (as % of total students) of Luxembourg in 2012?
Ensure brevity in your answer.  -8.84. What is the average Female students (as % of total students) in Heavily indebted poor countries per year?
Your answer should be very brief. 36.8. What is the average Female students (as % of total students) of Antigua and Barbuda per year?
Your answer should be compact. 45.56. What is the average Female students (as % of total students) of Burundi per year?
Offer a very short reply. 34.78. What is the average Female students (as % of total students) in Luxembourg per year?
Keep it short and to the point. 47.34. In the year 1972, what is the difference between the Female students (as % of total students) of Heavily indebted poor countries and Female students (as % of total students) of Antigua and Barbuda?
Your answer should be compact. 14.52. In the year 1972, what is the difference between the Female students (as % of total students) of Heavily indebted poor countries and Female students (as % of total students) of Burundi?
Your answer should be very brief. 7.42. In the year 1972, what is the difference between the Female students (as % of total students) of Heavily indebted poor countries and Female students (as % of total students) of Luxembourg?
Give a very brief answer. -17.25. In the year 1972, what is the difference between the Female students (as % of total students) in Antigua and Barbuda and Female students (as % of total students) in Burundi?
Your answer should be very brief. -7.1. In the year 1972, what is the difference between the Female students (as % of total students) in Antigua and Barbuda and Female students (as % of total students) in Luxembourg?
Offer a very short reply. -31.77. In the year 1972, what is the difference between the Female students (as % of total students) in Burundi and Female students (as % of total students) in Luxembourg?
Your response must be concise. -24.67. In the year 1974, what is the difference between the Female students (as % of total students) in Heavily indebted poor countries and Female students (as % of total students) in Antigua and Barbuda?
Ensure brevity in your answer.  -20.81. In the year 1974, what is the difference between the Female students (as % of total students) in Heavily indebted poor countries and Female students (as % of total students) in Burundi?
Your answer should be very brief. 0.1. In the year 1974, what is the difference between the Female students (as % of total students) of Heavily indebted poor countries and Female students (as % of total students) of Luxembourg?
Make the answer very short. -14.62. In the year 1974, what is the difference between the Female students (as % of total students) of Antigua and Barbuda and Female students (as % of total students) of Burundi?
Offer a terse response. 20.91. In the year 1974, what is the difference between the Female students (as % of total students) of Antigua and Barbuda and Female students (as % of total students) of Luxembourg?
Your response must be concise. 6.19. In the year 1974, what is the difference between the Female students (as % of total students) in Burundi and Female students (as % of total students) in Luxembourg?
Offer a very short reply. -14.73. In the year 1975, what is the difference between the Female students (as % of total students) in Heavily indebted poor countries and Female students (as % of total students) in Antigua and Barbuda?
Provide a succinct answer. -23.66. In the year 1975, what is the difference between the Female students (as % of total students) in Heavily indebted poor countries and Female students (as % of total students) in Burundi?
Offer a terse response. 2.29. In the year 1975, what is the difference between the Female students (as % of total students) in Heavily indebted poor countries and Female students (as % of total students) in Luxembourg?
Make the answer very short. -13.2. In the year 1975, what is the difference between the Female students (as % of total students) of Antigua and Barbuda and Female students (as % of total students) of Burundi?
Your response must be concise. 25.94. In the year 1975, what is the difference between the Female students (as % of total students) of Antigua and Barbuda and Female students (as % of total students) of Luxembourg?
Make the answer very short. 10.46. In the year 1975, what is the difference between the Female students (as % of total students) of Burundi and Female students (as % of total students) of Luxembourg?
Provide a succinct answer. -15.48. In the year 1977, what is the difference between the Female students (as % of total students) in Heavily indebted poor countries and Female students (as % of total students) in Antigua and Barbuda?
Make the answer very short. -15.67. In the year 1977, what is the difference between the Female students (as % of total students) of Heavily indebted poor countries and Female students (as % of total students) of Burundi?
Your response must be concise. -4.12. In the year 1977, what is the difference between the Female students (as % of total students) in Heavily indebted poor countries and Female students (as % of total students) in Luxembourg?
Provide a short and direct response. -9.29. In the year 1977, what is the difference between the Female students (as % of total students) in Antigua and Barbuda and Female students (as % of total students) in Burundi?
Offer a very short reply. 11.54. In the year 1977, what is the difference between the Female students (as % of total students) of Antigua and Barbuda and Female students (as % of total students) of Luxembourg?
Ensure brevity in your answer.  6.38. In the year 1977, what is the difference between the Female students (as % of total students) in Burundi and Female students (as % of total students) in Luxembourg?
Give a very brief answer. -5.17. In the year 1978, what is the difference between the Female students (as % of total students) in Heavily indebted poor countries and Female students (as % of total students) in Antigua and Barbuda?
Provide a short and direct response. -12.54. In the year 1978, what is the difference between the Female students (as % of total students) of Heavily indebted poor countries and Female students (as % of total students) of Burundi?
Offer a terse response. -5.33. In the year 1978, what is the difference between the Female students (as % of total students) of Heavily indebted poor countries and Female students (as % of total students) of Luxembourg?
Give a very brief answer. -10.99. In the year 1978, what is the difference between the Female students (as % of total students) of Antigua and Barbuda and Female students (as % of total students) of Burundi?
Your answer should be very brief. 7.22. In the year 1978, what is the difference between the Female students (as % of total students) of Antigua and Barbuda and Female students (as % of total students) of Luxembourg?
Give a very brief answer. 1.56. In the year 1978, what is the difference between the Female students (as % of total students) of Burundi and Female students (as % of total students) of Luxembourg?
Your answer should be compact. -5.66. In the year 2010, what is the difference between the Female students (as % of total students) in Heavily indebted poor countries and Female students (as % of total students) in Antigua and Barbuda?
Provide a short and direct response. -7.78. In the year 2010, what is the difference between the Female students (as % of total students) of Heavily indebted poor countries and Female students (as % of total students) of Burundi?
Keep it short and to the point. 4.26. In the year 2010, what is the difference between the Female students (as % of total students) of Heavily indebted poor countries and Female students (as % of total students) of Luxembourg?
Provide a succinct answer. -7.2. In the year 2010, what is the difference between the Female students (as % of total students) in Antigua and Barbuda and Female students (as % of total students) in Burundi?
Your answer should be very brief. 12.04. In the year 2010, what is the difference between the Female students (as % of total students) in Antigua and Barbuda and Female students (as % of total students) in Luxembourg?
Provide a succinct answer. 0.58. In the year 2010, what is the difference between the Female students (as % of total students) of Burundi and Female students (as % of total students) of Luxembourg?
Make the answer very short. -11.46. In the year 2011, what is the difference between the Female students (as % of total students) in Heavily indebted poor countries and Female students (as % of total students) in Antigua and Barbuda?
Provide a short and direct response. -0.99. In the year 2011, what is the difference between the Female students (as % of total students) in Heavily indebted poor countries and Female students (as % of total students) in Burundi?
Make the answer very short. 4.07. In the year 2011, what is the difference between the Female students (as % of total students) in Heavily indebted poor countries and Female students (as % of total students) in Luxembourg?
Offer a very short reply. -4.42. In the year 2011, what is the difference between the Female students (as % of total students) in Antigua and Barbuda and Female students (as % of total students) in Burundi?
Provide a short and direct response. 5.05. In the year 2011, what is the difference between the Female students (as % of total students) in Antigua and Barbuda and Female students (as % of total students) in Luxembourg?
Your answer should be very brief. -3.43. In the year 2011, what is the difference between the Female students (as % of total students) of Burundi and Female students (as % of total students) of Luxembourg?
Make the answer very short. -8.48. In the year 2012, what is the difference between the Female students (as % of total students) in Heavily indebted poor countries and Female students (as % of total students) in Antigua and Barbuda?
Keep it short and to the point. -3.13. In the year 2012, what is the difference between the Female students (as % of total students) in Heavily indebted poor countries and Female students (as % of total students) in Burundi?
Offer a terse response. 7.5. In the year 2012, what is the difference between the Female students (as % of total students) of Heavily indebted poor countries and Female students (as % of total students) of Luxembourg?
Offer a very short reply. -7.33. In the year 2012, what is the difference between the Female students (as % of total students) of Antigua and Barbuda and Female students (as % of total students) of Burundi?
Give a very brief answer. 10.63. In the year 2012, what is the difference between the Female students (as % of total students) of Antigua and Barbuda and Female students (as % of total students) of Luxembourg?
Provide a succinct answer. -4.21. In the year 2012, what is the difference between the Female students (as % of total students) of Burundi and Female students (as % of total students) of Luxembourg?
Offer a terse response. -14.83. What is the ratio of the Female students (as % of total students) in Heavily indebted poor countries in 1972 to that in 1974?
Make the answer very short. 0.94. What is the ratio of the Female students (as % of total students) of Antigua and Barbuda in 1972 to that in 1974?
Ensure brevity in your answer.  0.33. What is the ratio of the Female students (as % of total students) of Burundi in 1972 to that in 1974?
Keep it short and to the point. 0.73. What is the ratio of the Female students (as % of total students) of Luxembourg in 1972 to that in 1974?
Provide a short and direct response. 1.01. What is the ratio of the Female students (as % of total students) in Heavily indebted poor countries in 1972 to that in 1975?
Provide a succinct answer. 0.93. What is the ratio of the Female students (as % of total students) in Antigua and Barbuda in 1972 to that in 1975?
Give a very brief answer. 0.31. What is the ratio of the Female students (as % of total students) of Burundi in 1972 to that in 1975?
Ensure brevity in your answer.  0.77. What is the ratio of the Female students (as % of total students) in Luxembourg in 1972 to that in 1975?
Offer a terse response. 1.04. What is the ratio of the Female students (as % of total students) in Heavily indebted poor countries in 1972 to that in 1977?
Make the answer very short. 0.95. What is the ratio of the Female students (as % of total students) in Antigua and Barbuda in 1972 to that in 1977?
Provide a short and direct response. 0.36. What is the ratio of the Female students (as % of total students) in Burundi in 1972 to that in 1977?
Offer a very short reply. 0.65. What is the ratio of the Female students (as % of total students) of Luxembourg in 1972 to that in 1977?
Your answer should be compact. 1.14. What is the ratio of the Female students (as % of total students) of Heavily indebted poor countries in 1972 to that in 1978?
Provide a short and direct response. 0.95. What is the ratio of the Female students (as % of total students) in Antigua and Barbuda in 1972 to that in 1978?
Give a very brief answer. 0.38. What is the ratio of the Female students (as % of total students) in Burundi in 1972 to that in 1978?
Your answer should be compact. 0.63. What is the ratio of the Female students (as % of total students) of Luxembourg in 1972 to that in 1978?
Provide a short and direct response. 1.1. What is the ratio of the Female students (as % of total students) of Heavily indebted poor countries in 1972 to that in 2010?
Provide a short and direct response. 0.81. What is the ratio of the Female students (as % of total students) in Antigua and Barbuda in 1972 to that in 2010?
Keep it short and to the point. 0.37. What is the ratio of the Female students (as % of total students) in Burundi in 1972 to that in 2010?
Your answer should be very brief. 0.7. What is the ratio of the Female students (as % of total students) in Luxembourg in 1972 to that in 2010?
Keep it short and to the point. 1.05. What is the ratio of the Female students (as % of total students) in Heavily indebted poor countries in 1972 to that in 2011?
Keep it short and to the point. 0.75. What is the ratio of the Female students (as % of total students) of Antigua and Barbuda in 1972 to that in 2011?
Offer a very short reply. 0.41. What is the ratio of the Female students (as % of total students) in Burundi in 1972 to that in 2011?
Give a very brief answer. 0.64. What is the ratio of the Female students (as % of total students) in Luxembourg in 1972 to that in 2011?
Your response must be concise. 1.05. What is the ratio of the Female students (as % of total students) of Heavily indebted poor countries in 1972 to that in 2012?
Your response must be concise. 0.8. What is the ratio of the Female students (as % of total students) in Antigua and Barbuda in 1972 to that in 2012?
Make the answer very short. 0.41. What is the ratio of the Female students (as % of total students) in Burundi in 1972 to that in 2012?
Your response must be concise. 0.76. What is the ratio of the Female students (as % of total students) in Luxembourg in 1972 to that in 2012?
Offer a terse response. 1.04. What is the ratio of the Female students (as % of total students) of Heavily indebted poor countries in 1974 to that in 1975?
Your answer should be compact. 0.99. What is the ratio of the Female students (as % of total students) of Antigua and Barbuda in 1974 to that in 1975?
Ensure brevity in your answer.  0.95. What is the ratio of the Female students (as % of total students) in Burundi in 1974 to that in 1975?
Your answer should be compact. 1.06. What is the ratio of the Female students (as % of total students) in Luxembourg in 1974 to that in 1975?
Provide a short and direct response. 1.02. What is the ratio of the Female students (as % of total students) of Heavily indebted poor countries in 1974 to that in 1977?
Provide a short and direct response. 1.01. What is the ratio of the Female students (as % of total students) in Antigua and Barbuda in 1974 to that in 1977?
Give a very brief answer. 1.11. What is the ratio of the Female students (as % of total students) in Burundi in 1974 to that in 1977?
Offer a very short reply. 0.89. What is the ratio of the Female students (as % of total students) in Luxembourg in 1974 to that in 1977?
Your answer should be very brief. 1.13. What is the ratio of the Female students (as % of total students) of Heavily indebted poor countries in 1974 to that in 1978?
Provide a succinct answer. 1.01. What is the ratio of the Female students (as % of total students) in Antigua and Barbuda in 1974 to that in 1978?
Your answer should be compact. 1.18. What is the ratio of the Female students (as % of total students) in Burundi in 1974 to that in 1978?
Your answer should be very brief. 0.87. What is the ratio of the Female students (as % of total students) in Luxembourg in 1974 to that in 1978?
Ensure brevity in your answer.  1.09. What is the ratio of the Female students (as % of total students) in Heavily indebted poor countries in 1974 to that in 2010?
Give a very brief answer. 0.86. What is the ratio of the Female students (as % of total students) in Antigua and Barbuda in 1974 to that in 2010?
Offer a terse response. 1.15. What is the ratio of the Female students (as % of total students) of Burundi in 1974 to that in 2010?
Ensure brevity in your answer.  0.95. What is the ratio of the Female students (as % of total students) of Luxembourg in 1974 to that in 2010?
Make the answer very short. 1.03. What is the ratio of the Female students (as % of total students) of Heavily indebted poor countries in 1974 to that in 2011?
Your response must be concise. 0.8. What is the ratio of the Female students (as % of total students) of Antigua and Barbuda in 1974 to that in 2011?
Keep it short and to the point. 1.25. What is the ratio of the Female students (as % of total students) in Burundi in 1974 to that in 2011?
Provide a succinct answer. 0.88. What is the ratio of the Female students (as % of total students) of Heavily indebted poor countries in 1974 to that in 2012?
Keep it short and to the point. 0.85. What is the ratio of the Female students (as % of total students) in Antigua and Barbuda in 1974 to that in 2012?
Give a very brief answer. 1.27. What is the ratio of the Female students (as % of total students) of Burundi in 1974 to that in 2012?
Offer a very short reply. 1.04. What is the ratio of the Female students (as % of total students) in Luxembourg in 1974 to that in 2012?
Your response must be concise. 1.03. What is the ratio of the Female students (as % of total students) in Heavily indebted poor countries in 1975 to that in 1977?
Keep it short and to the point. 1.02. What is the ratio of the Female students (as % of total students) in Antigua and Barbuda in 1975 to that in 1977?
Make the answer very short. 1.17. What is the ratio of the Female students (as % of total students) in Burundi in 1975 to that in 1977?
Your answer should be compact. 0.85. What is the ratio of the Female students (as % of total students) in Luxembourg in 1975 to that in 1977?
Offer a very short reply. 1.1. What is the ratio of the Female students (as % of total students) of Heavily indebted poor countries in 1975 to that in 1978?
Make the answer very short. 1.02. What is the ratio of the Female students (as % of total students) of Antigua and Barbuda in 1975 to that in 1978?
Your response must be concise. 1.25. What is the ratio of the Female students (as % of total students) of Burundi in 1975 to that in 1978?
Offer a very short reply. 0.82. What is the ratio of the Female students (as % of total students) in Luxembourg in 1975 to that in 1978?
Keep it short and to the point. 1.06. What is the ratio of the Female students (as % of total students) of Heavily indebted poor countries in 1975 to that in 2010?
Ensure brevity in your answer.  0.87. What is the ratio of the Female students (as % of total students) of Antigua and Barbuda in 1975 to that in 2010?
Offer a very short reply. 1.22. What is the ratio of the Female students (as % of total students) of Burundi in 1975 to that in 2010?
Offer a terse response. 0.9. What is the ratio of the Female students (as % of total students) of Heavily indebted poor countries in 1975 to that in 2011?
Give a very brief answer. 0.81. What is the ratio of the Female students (as % of total students) of Antigua and Barbuda in 1975 to that in 2011?
Offer a very short reply. 1.33. What is the ratio of the Female students (as % of total students) in Burundi in 1975 to that in 2011?
Offer a terse response. 0.83. What is the ratio of the Female students (as % of total students) of Luxembourg in 1975 to that in 2011?
Offer a terse response. 1.01. What is the ratio of the Female students (as % of total students) of Heavily indebted poor countries in 1975 to that in 2012?
Make the answer very short. 0.86. What is the ratio of the Female students (as % of total students) of Antigua and Barbuda in 1975 to that in 2012?
Offer a terse response. 1.34. What is the ratio of the Female students (as % of total students) in Burundi in 1975 to that in 2012?
Your answer should be compact. 0.98. What is the ratio of the Female students (as % of total students) of Heavily indebted poor countries in 1977 to that in 1978?
Keep it short and to the point. 1. What is the ratio of the Female students (as % of total students) of Antigua and Barbuda in 1977 to that in 1978?
Your response must be concise. 1.07. What is the ratio of the Female students (as % of total students) in Burundi in 1977 to that in 1978?
Your response must be concise. 0.97. What is the ratio of the Female students (as % of total students) in Luxembourg in 1977 to that in 1978?
Ensure brevity in your answer.  0.96. What is the ratio of the Female students (as % of total students) of Heavily indebted poor countries in 1977 to that in 2010?
Your answer should be compact. 0.85. What is the ratio of the Female students (as % of total students) of Antigua and Barbuda in 1977 to that in 2010?
Keep it short and to the point. 1.04. What is the ratio of the Female students (as % of total students) of Burundi in 1977 to that in 2010?
Make the answer very short. 1.07. What is the ratio of the Female students (as % of total students) of Luxembourg in 1977 to that in 2010?
Your answer should be very brief. 0.92. What is the ratio of the Female students (as % of total students) in Heavily indebted poor countries in 1977 to that in 2011?
Give a very brief answer. 0.8. What is the ratio of the Female students (as % of total students) of Antigua and Barbuda in 1977 to that in 2011?
Your answer should be compact. 1.13. What is the ratio of the Female students (as % of total students) in Burundi in 1977 to that in 2011?
Ensure brevity in your answer.  0.98. What is the ratio of the Female students (as % of total students) in Luxembourg in 1977 to that in 2011?
Keep it short and to the point. 0.92. What is the ratio of the Female students (as % of total students) in Heavily indebted poor countries in 1977 to that in 2012?
Give a very brief answer. 0.85. What is the ratio of the Female students (as % of total students) of Antigua and Barbuda in 1977 to that in 2012?
Your response must be concise. 1.14. What is the ratio of the Female students (as % of total students) in Burundi in 1977 to that in 2012?
Make the answer very short. 1.16. What is the ratio of the Female students (as % of total students) in Luxembourg in 1977 to that in 2012?
Your response must be concise. 0.91. What is the ratio of the Female students (as % of total students) of Heavily indebted poor countries in 1978 to that in 2010?
Ensure brevity in your answer.  0.85. What is the ratio of the Female students (as % of total students) of Antigua and Barbuda in 1978 to that in 2010?
Your response must be concise. 0.97. What is the ratio of the Female students (as % of total students) in Burundi in 1978 to that in 2010?
Provide a succinct answer. 1.1. What is the ratio of the Female students (as % of total students) of Luxembourg in 1978 to that in 2010?
Offer a very short reply. 0.95. What is the ratio of the Female students (as % of total students) of Heavily indebted poor countries in 1978 to that in 2011?
Give a very brief answer. 0.79. What is the ratio of the Female students (as % of total students) of Antigua and Barbuda in 1978 to that in 2011?
Ensure brevity in your answer.  1.06. What is the ratio of the Female students (as % of total students) in Burundi in 1978 to that in 2011?
Give a very brief answer. 1.01. What is the ratio of the Female students (as % of total students) of Luxembourg in 1978 to that in 2011?
Offer a terse response. 0.95. What is the ratio of the Female students (as % of total students) in Heavily indebted poor countries in 1978 to that in 2012?
Your answer should be compact. 0.84. What is the ratio of the Female students (as % of total students) in Antigua and Barbuda in 1978 to that in 2012?
Make the answer very short. 1.07. What is the ratio of the Female students (as % of total students) of Burundi in 1978 to that in 2012?
Your response must be concise. 1.2. What is the ratio of the Female students (as % of total students) in Luxembourg in 1978 to that in 2012?
Ensure brevity in your answer.  0.94. What is the ratio of the Female students (as % of total students) in Heavily indebted poor countries in 2010 to that in 2011?
Make the answer very short. 0.93. What is the ratio of the Female students (as % of total students) of Antigua and Barbuda in 2010 to that in 2011?
Your answer should be very brief. 1.09. What is the ratio of the Female students (as % of total students) in Burundi in 2010 to that in 2011?
Give a very brief answer. 0.92. What is the ratio of the Female students (as % of total students) of Burundi in 2010 to that in 2012?
Your answer should be very brief. 1.09. What is the ratio of the Female students (as % of total students) in Luxembourg in 2010 to that in 2012?
Give a very brief answer. 0.99. What is the ratio of the Female students (as % of total students) in Heavily indebted poor countries in 2011 to that in 2012?
Ensure brevity in your answer.  1.06. What is the ratio of the Female students (as % of total students) of Antigua and Barbuda in 2011 to that in 2012?
Provide a short and direct response. 1.01. What is the ratio of the Female students (as % of total students) of Burundi in 2011 to that in 2012?
Make the answer very short. 1.18. What is the difference between the highest and the second highest Female students (as % of total students) in Heavily indebted poor countries?
Your answer should be compact. 2.56. What is the difference between the highest and the second highest Female students (as % of total students) in Antigua and Barbuda?
Ensure brevity in your answer.  3.2. What is the difference between the highest and the second highest Female students (as % of total students) in Burundi?
Offer a terse response. 0.49. What is the difference between the highest and the second highest Female students (as % of total students) in Luxembourg?
Keep it short and to the point. 0.63. What is the difference between the highest and the lowest Female students (as % of total students) of Heavily indebted poor countries?
Offer a very short reply. 10.62. What is the difference between the highest and the lowest Female students (as % of total students) of Antigua and Barbuda?
Make the answer very short. 40.52. What is the difference between the highest and the lowest Female students (as % of total students) in Burundi?
Your answer should be very brief. 14.47. What is the difference between the highest and the lowest Female students (as % of total students) in Luxembourg?
Make the answer very short. 6.14. 